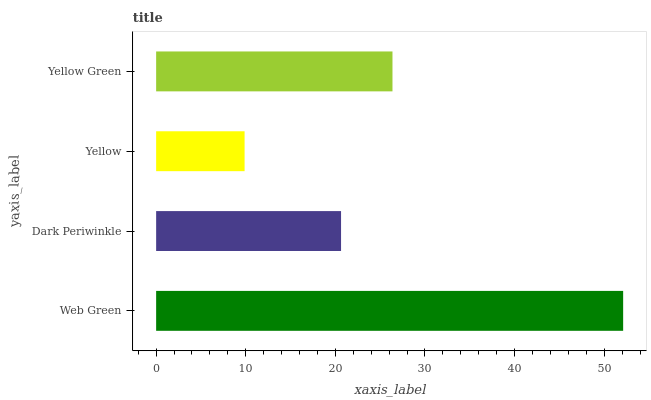Is Yellow the minimum?
Answer yes or no. Yes. Is Web Green the maximum?
Answer yes or no. Yes. Is Dark Periwinkle the minimum?
Answer yes or no. No. Is Dark Periwinkle the maximum?
Answer yes or no. No. Is Web Green greater than Dark Periwinkle?
Answer yes or no. Yes. Is Dark Periwinkle less than Web Green?
Answer yes or no. Yes. Is Dark Periwinkle greater than Web Green?
Answer yes or no. No. Is Web Green less than Dark Periwinkle?
Answer yes or no. No. Is Yellow Green the high median?
Answer yes or no. Yes. Is Dark Periwinkle the low median?
Answer yes or no. Yes. Is Web Green the high median?
Answer yes or no. No. Is Web Green the low median?
Answer yes or no. No. 